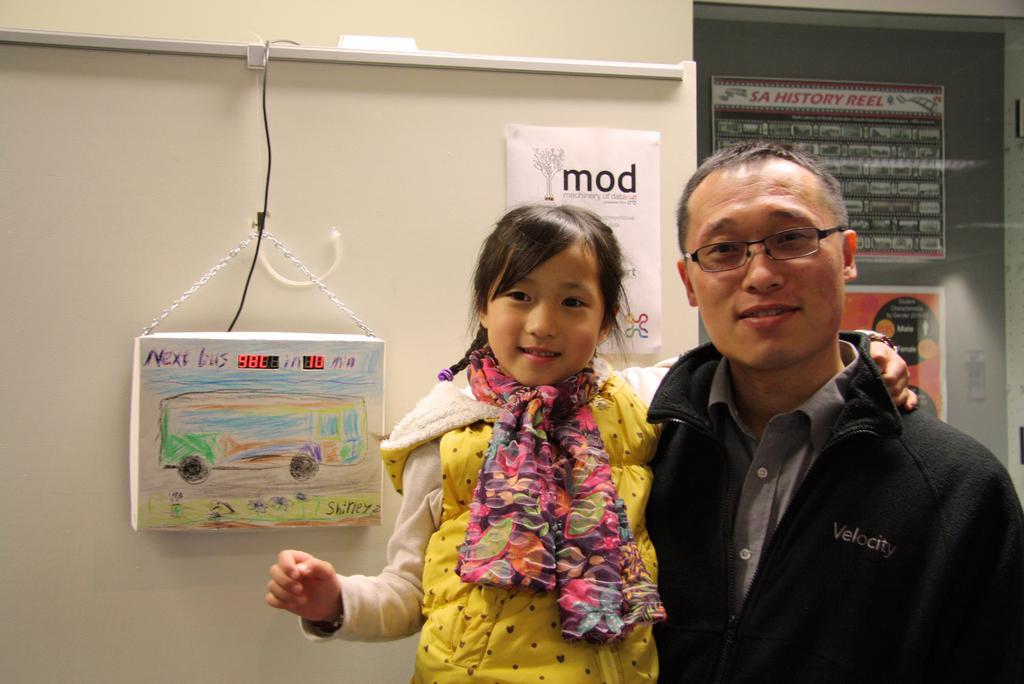In one or two sentences, can you explain what this image depicts? A man is standing, he wore black color coat and also holding the baby, this baby wore yellow color coat. Behind them there is the wall. 